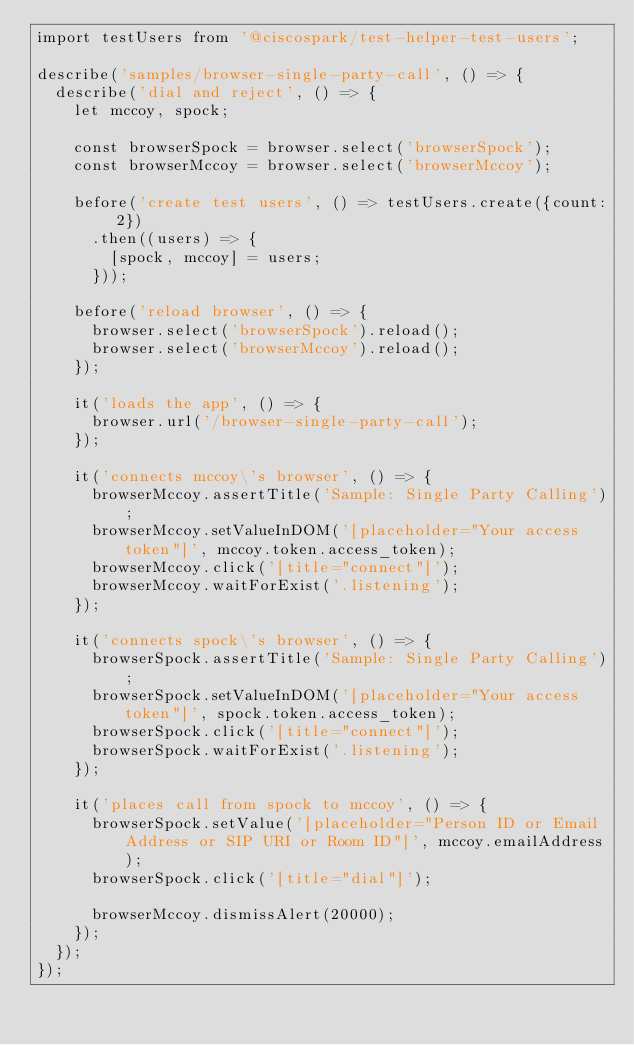<code> <loc_0><loc_0><loc_500><loc_500><_JavaScript_>import testUsers from '@ciscospark/test-helper-test-users';

describe('samples/browser-single-party-call', () => {
  describe('dial and reject', () => {
    let mccoy, spock;

    const browserSpock = browser.select('browserSpock');
    const browserMccoy = browser.select('browserMccoy');

    before('create test users', () => testUsers.create({count: 2})
      .then((users) => {
        [spock, mccoy] = users;
      }));

    before('reload browser', () => {
      browser.select('browserSpock').reload();
      browser.select('browserMccoy').reload();
    });

    it('loads the app', () => {
      browser.url('/browser-single-party-call');
    });

    it('connects mccoy\'s browser', () => {
      browserMccoy.assertTitle('Sample: Single Party Calling');
      browserMccoy.setValueInDOM('[placeholder="Your access token"]', mccoy.token.access_token);
      browserMccoy.click('[title="connect"]');
      browserMccoy.waitForExist('.listening');
    });

    it('connects spock\'s browser', () => {
      browserSpock.assertTitle('Sample: Single Party Calling');
      browserSpock.setValueInDOM('[placeholder="Your access token"]', spock.token.access_token);
      browserSpock.click('[title="connect"]');
      browserSpock.waitForExist('.listening');
    });

    it('places call from spock to mccoy', () => {
      browserSpock.setValue('[placeholder="Person ID or Email Address or SIP URI or Room ID"]', mccoy.emailAddress);
      browserSpock.click('[title="dial"]');

      browserMccoy.dismissAlert(20000);
    });
  });
});
</code> 